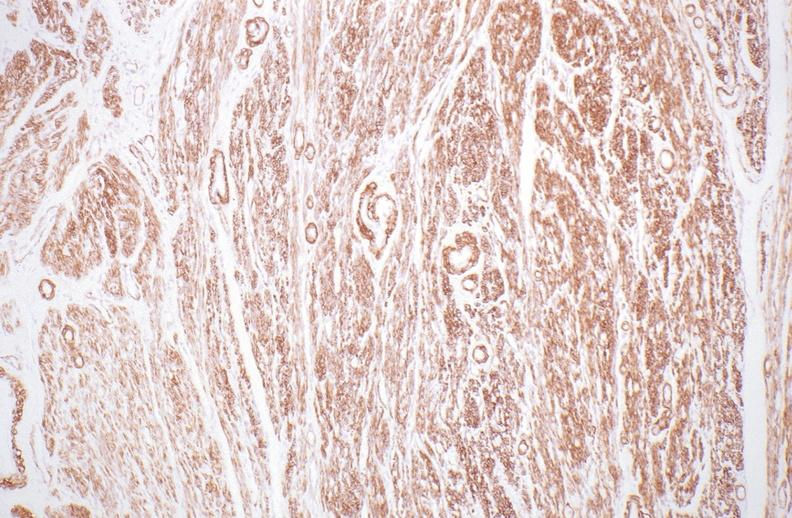do fibroma stain?
Answer the question using a single word or phrase. No 